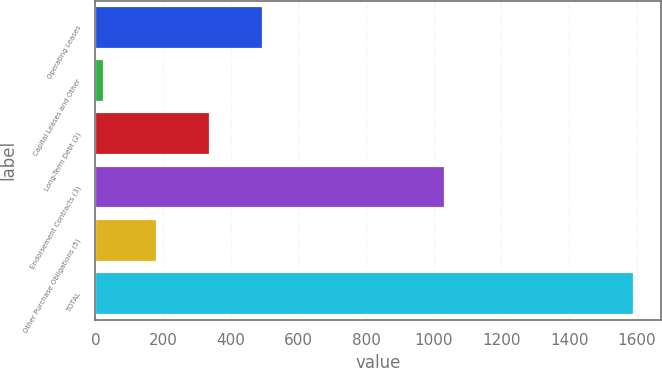Convert chart to OTSL. <chart><loc_0><loc_0><loc_500><loc_500><bar_chart><fcel>Operating Leases<fcel>Capital Leases and Other<fcel>Long-Term Debt (2)<fcel>Endorsement Contracts (3)<fcel>Other Purchase Obligations (5)<fcel>TOTAL<nl><fcel>495.8<fcel>26<fcel>339.2<fcel>1032<fcel>182.6<fcel>1592<nl></chart> 